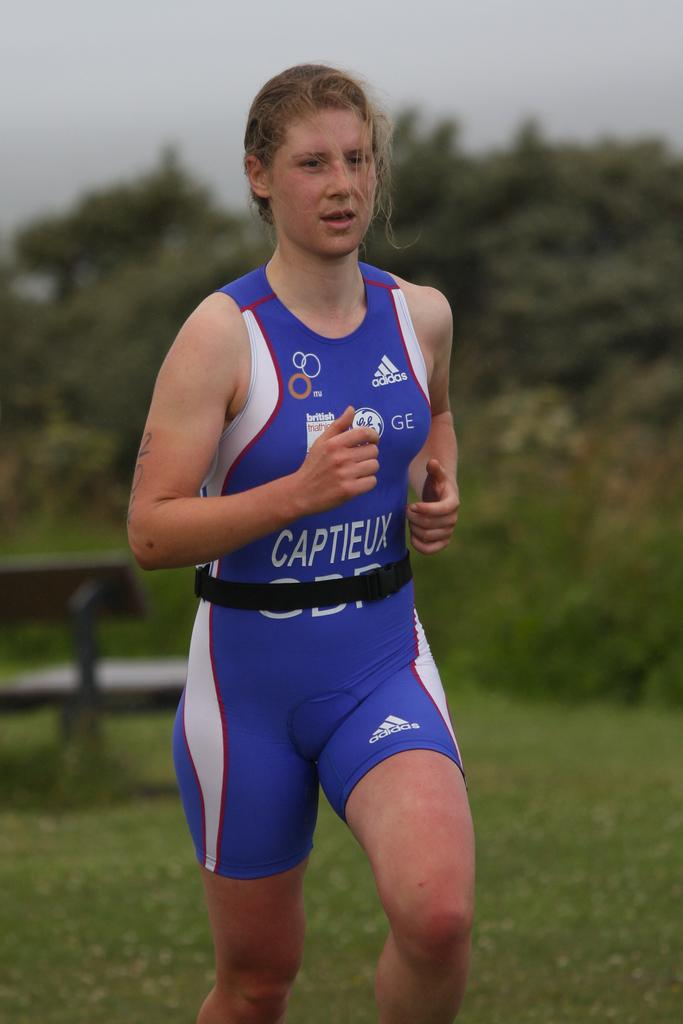<image>
Relay a brief, clear account of the picture shown. A fatigued looking runner wears a uniform reading Captieux just above the beltline. 